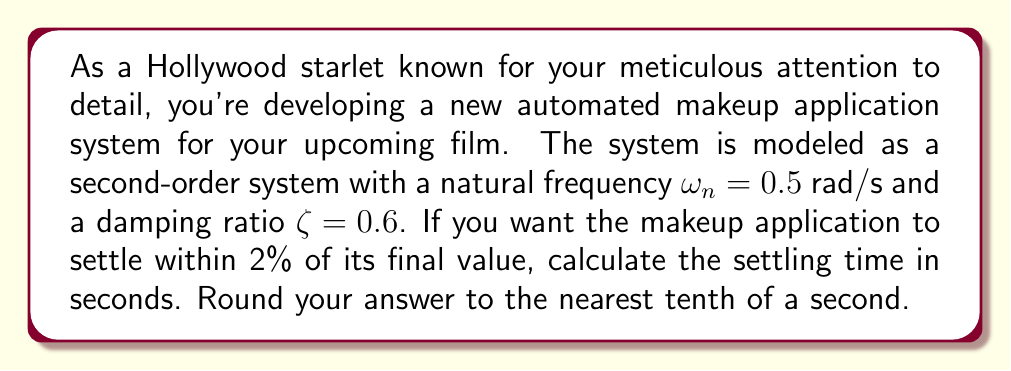Solve this math problem. To solve this problem, we'll use the formula for settling time of a second-order system:

$$T_s = \frac{4}{\zeta \omega_n}$$

Where:
$T_s$ is the settling time
$\zeta$ is the damping ratio
$\omega_n$ is the natural frequency

We're given:
$\zeta = 0.6$
$\omega_n = 0.5$ rad/s

Let's substitute these values into the formula:

$$T_s = \frac{4}{0.6 \times 0.5}$$

$$T_s = \frac{4}{0.3}$$

$$T_s = 13.33333... \text{ seconds}$$

Rounding to the nearest tenth of a second:

$$T_s \approx 13.3 \text{ seconds}$$

This means that your automated makeup application system will settle to within 2% of its final value after approximately 13.3 seconds.
Answer: 13.3 seconds 